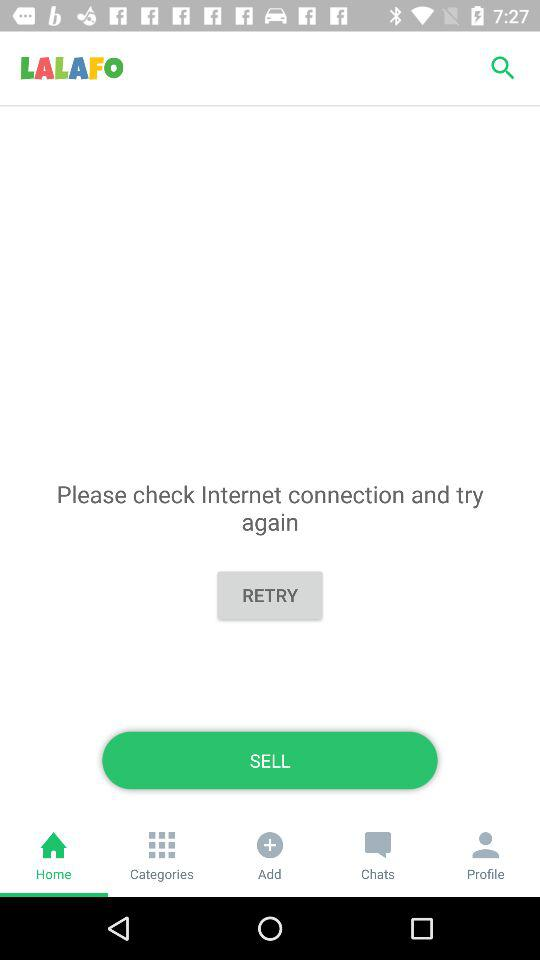What is the name of the application? The application name is "LALAFO". 